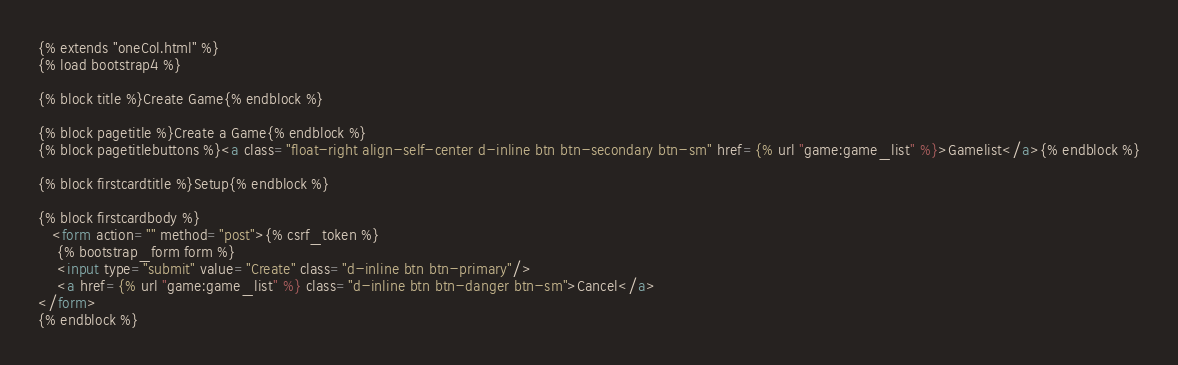Convert code to text. <code><loc_0><loc_0><loc_500><loc_500><_HTML_>{% extends "oneCol.html" %}
{% load bootstrap4 %}

{% block title %}Create Game{% endblock %}

{% block pagetitle %}Create a Game{% endblock %}
{% block pagetitlebuttons %}<a class="float-right align-self-center d-inline btn btn-secondary btn-sm" href={% url "game:game_list" %}>Gamelist</a>{% endblock %}

{% block firstcardtitle %}Setup{% endblock %}

{% block firstcardbody %}
   <form action="" method="post">{% csrf_token %}
    {% bootstrap_form form %}
    <input type="submit" value="Create" class="d-inline btn btn-primary"/>
    <a href={% url "game:game_list" %} class="d-inline btn btn-danger btn-sm">Cancel</a>
</form>
{% endblock %}</code> 